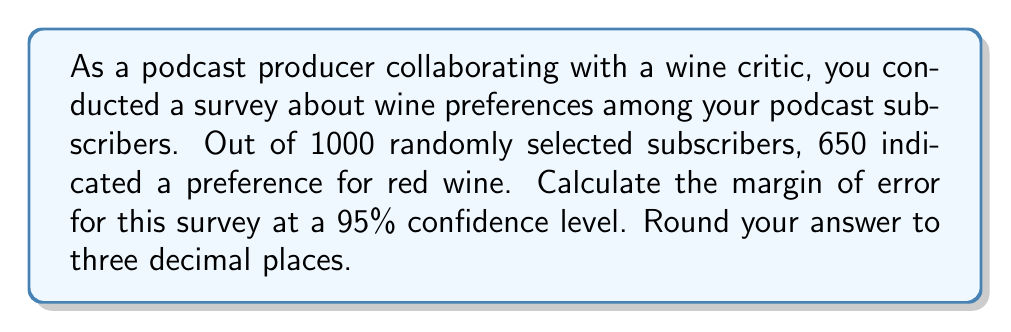Show me your answer to this math problem. To calculate the margin of error, we'll follow these steps:

1. Identify the components:
   - Sample size (n) = 1000
   - Sample proportion (p̂) = 650/1000 = 0.65
   - Confidence level = 95% (z-score = 1.96)

2. Calculate the standard error (SE):
   $$ SE = \sqrt{\frac{p̂(1-p̂)}{n}} $$
   $$ SE = \sqrt{\frac{0.65(1-0.65)}{1000}} = \sqrt{\frac{0.2275}{1000}} = 0.015083 $$

3. Calculate the margin of error (ME):
   $$ ME = z \times SE $$
   Where z is the z-score for the 95% confidence level (1.96)
   $$ ME = 1.96 \times 0.015083 = 0.029563 $$

4. Round to three decimal places:
   $$ ME ≈ 0.030 $$

This means that we can be 95% confident that the true proportion of all podcast subscribers who prefer red wine is within ±3.0 percentage points of our sample proportion (65%).
Answer: 0.030 